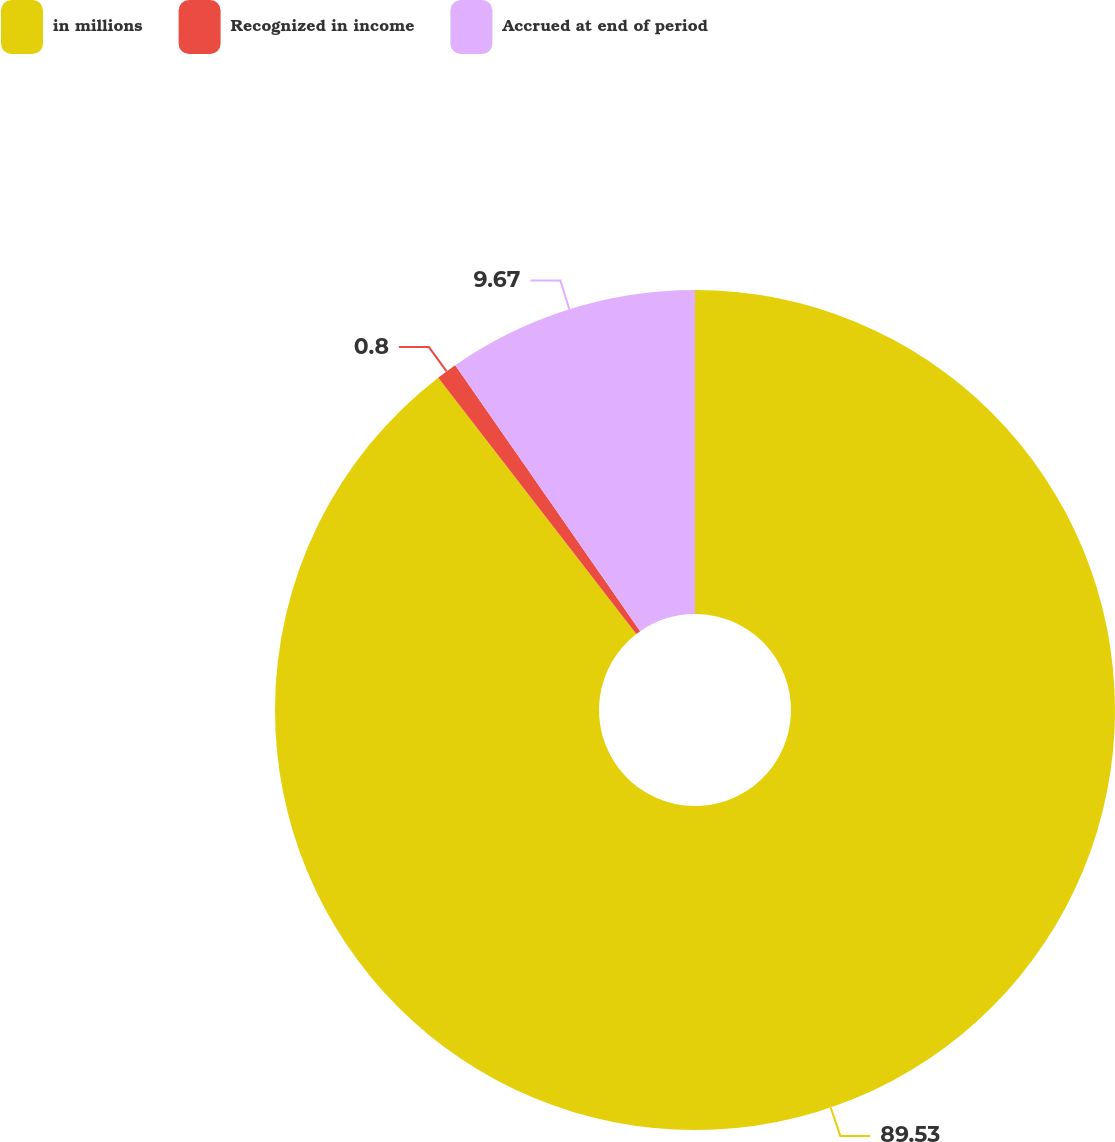Convert chart to OTSL. <chart><loc_0><loc_0><loc_500><loc_500><pie_chart><fcel>in millions<fcel>Recognized in income<fcel>Accrued at end of period<nl><fcel>89.53%<fcel>0.8%<fcel>9.67%<nl></chart> 